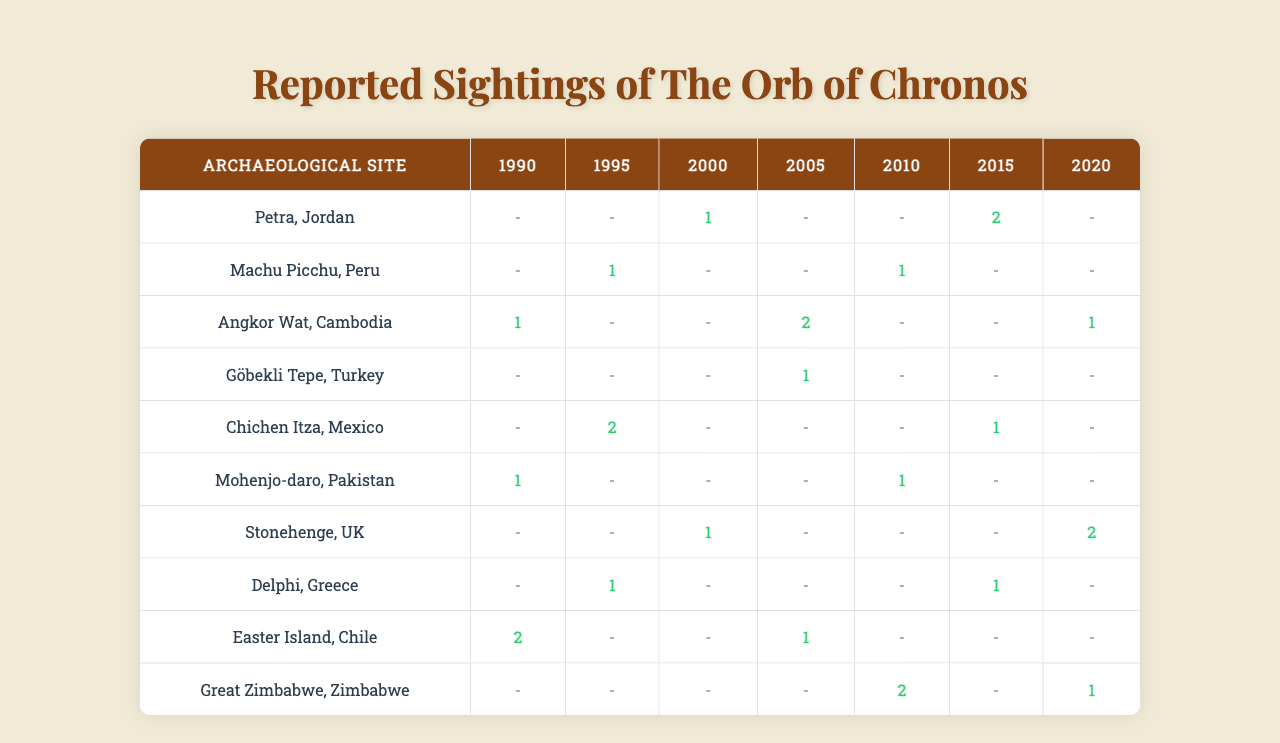What archaeological site recorded the highest number of sightings for The Orb of Chronos in 2010? In 2010, the number of sightings for each site is as follows: Petra (0), Machu Picchu (1), Angkor Wat (0), Göbekli Tepe (0), Chichen Itza (0), Mohenjo-daro (1), Stonehenge (0), Delphi (0), Easter Island (0), Great Zimbabwe (2). The highest number is 2 at Great Zimbabwe.
Answer: Great Zimbabwe Which site had the most consistent sightings across all years from 1990 to 2020? To determine consistency, I check the number of sightings for each site. For example, Petra had 0, 0, 1, 0, 0, 2, 0 (varied), while Great Zimbabwe had 0, 0, 0, 0, 2, 0, 1 (also varied). Upon checking the data, it appears that Mohenjo-daro had sightings (1, 0, 0, 0, 1, 0, 0) which were more consistent (only varying between 0 and 1 except for one instance) compared to other sites.
Answer: Mohenjo-daro What is the total count of sightings for The Orb of Chronos from all sites in 1995? Summing the sightings from all sites for 1995 gives: 0 (Petra) + 1 (Machu Picchu) + 0 (Angkor Wat) + 0 (Göbekli Tepe) + 2 (Chichen Itza) + 0 (Mohenjo-daro) + 0 (Stonehenge) + 1 (Delphi) + 0 (Easter Island) + 0 (Great Zimbabwe) = 4.
Answer: 4 Did any site record sightings in every year from 1990 to 2020? Checking each site, I see that no site has non-zero sightings for every year. For example, Angkor Wat had zero sightings in 1990, 1995, and several other years. Thus, there is no such site that fits this criterion.
Answer: No Which year saw the highest total sightings across all the archaeological sites and what was that number? By inspecting the data for each year: for 1990: 4, 1995: 4, 2000: 2, 2005: 3, 2010: 3, 2015: 3, 2020: 4. The highest value appeared in the years 1990, 1995, and 2020, each with a total of 4 sightings.
Answer: 4 If we consider the average number of sightings across all sites in 2005, what is that average? For 2005, the sightings are: 0 (Petra) + 0 (Machu Picchu) + 2 (Angkor Wat) + 1 (Göbekli Tepe) + 0 (Chichen Itza) + 0 (Mohenjo-daro) + 0 (Stonehenge) + 0 (Delphi) + 1 (Easter Island) + 0 (Great Zimbabwe) = 4 sightings. With 10 sites, the average is 4/10 = 0.4.
Answer: 0.4 Which site has the least sightings overall? Adding all sightings across the years for each site indicates: Petra: 3, Machu Picchu: 2, Angkor Wat: 4, Göbekli Tepe: 1, Chichen Itza: 3, Mohenjo-daro: 2, Stonehenge: 3, Delphi: 2, Easter Island: 3, Great Zimbabwe: 3. The site with the least sightings is Göbekli Tepe with a total of 1 sighting.
Answer: Göbekli Tepe Looking at the sightings data, which archaeological site had sightings in the year 2000 only? For the year 2000, I will list each site's sightings: Petra (1), Machu Picchu (0), Angkor Wat (0), Göbekli Tepe (0), Chichen Itza (0), Mohenjo-daro (0), Stonehenge (1), Delphi (0), Easter Island (0), Great Zimbabwe (0). Only Petra and Stonehenge have sightings (both have 1 sighting). Thus, there is no site that had sightings exclusively in 2000.
Answer: No site exclusively What percentage of sightings for The Orb of Chronos occurred in the year 2015 compared to the total sightings recorded across all years? In 2015, total sightings are: 2 (Petra) + 0 (Machu Picchu) + 0 (Angkor Wat) + 0 (Göbekli Tepe) + 1 (Chichen Itza) + 0 (Mohenjo-daro) + 0 (Stonehenge) + 1 (Delphi) + 0 (Easter Island) + 0 (Great Zimbabwe) = 4. The overall total is 19. The percentage is (4/19) * 100 = approximately 21.05%.
Answer: Approximately 21.05% What site had an equal number of sightings in 2005 and 2015? Checking the data for 2005 and 2015: 2005 sightings are: Petra (0), Machu Picchu (0), Angkor Wat (2), Göbekli Tepe (1), Chichen Itza (0), Mohenjo-daro (0), Stonehenge (0), Delphi (0), Easter Island (1), Great Zimbabwe (0); 2015 sightings are: Petra (2), Machu Picchu (0), Angkor Wat (0), Göbekli Tepe (0), Chichen Itza (1), Mohenjo-daro (0), Stonehenge (0), Delphi (1), Easter Island (0), Great Zimbabwe (0). The only site with equal sightings (0) is Machu Picchu.
Answer: Machu Picchu 